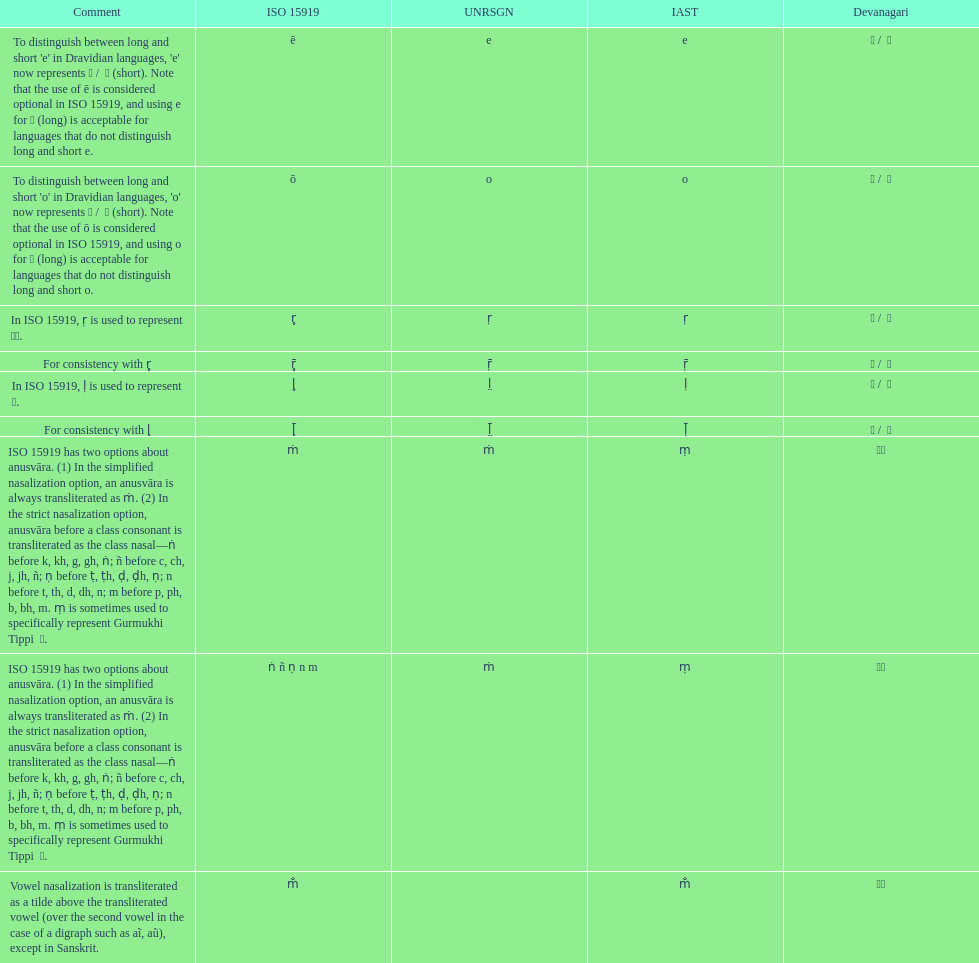What is the total number of translations? 8. Could you parse the entire table as a dict? {'header': ['Comment', 'ISO 15919', 'UNRSGN', 'IAST', 'Devanagari'], 'rows': [["To distinguish between long and short 'e' in Dravidian languages, 'e' now represents ऎ / \xa0ॆ (short). Note that the use of ē is considered optional in ISO 15919, and using e for ए (long) is acceptable for languages that do not distinguish long and short e.", 'ē', 'e', 'e', 'ए / \xa0े'], ["To distinguish between long and short 'o' in Dravidian languages, 'o' now represents ऒ / \xa0ॊ (short). Note that the use of ō is considered optional in ISO 15919, and using o for ओ (long) is acceptable for languages that do not distinguish long and short o.", 'ō', 'o', 'o', 'ओ / \xa0ो'], ['In ISO 15919, ṛ is used to represent ड़.', 'r̥', 'ṛ', 'ṛ', 'ऋ / \xa0ृ'], ['For consistency with r̥', 'r̥̄', 'ṝ', 'ṝ', 'ॠ / \xa0ॄ'], ['In ISO 15919, ḷ is used to represent ळ.', 'l̥', 'l̤', 'ḷ', 'ऌ / \xa0ॢ'], ['For consistency with l̥', 'l̥̄', 'l̤̄', 'ḹ', 'ॡ / \xa0ॣ'], ['ISO 15919 has two options about anusvāra. (1) In the simplified nasalization option, an anusvāra is always transliterated as ṁ. (2) In the strict nasalization option, anusvāra before a class consonant is transliterated as the class nasal—ṅ before k, kh, g, gh, ṅ; ñ before c, ch, j, jh, ñ; ṇ before ṭ, ṭh, ḍ, ḍh, ṇ; n before t, th, d, dh, n; m before p, ph, b, bh, m. ṃ is sometimes used to specifically represent Gurmukhi Tippi \xa0ੰ.', 'ṁ', 'ṁ', 'ṃ', '◌ं'], ['ISO 15919 has two options about anusvāra. (1) In the simplified nasalization option, an anusvāra is always transliterated as ṁ. (2) In the strict nasalization option, anusvāra before a class consonant is transliterated as the class nasal—ṅ before k, kh, g, gh, ṅ; ñ before c, ch, j, jh, ñ; ṇ before ṭ, ṭh, ḍ, ḍh, ṇ; n before t, th, d, dh, n; m before p, ph, b, bh, m. ṃ is sometimes used to specifically represent Gurmukhi Tippi \xa0ੰ.', 'ṅ ñ ṇ n m', 'ṁ', 'ṃ', '◌ं'], ['Vowel nasalization is transliterated as a tilde above the transliterated vowel (over the second vowel in the case of a digraph such as aĩ, aũ), except in Sanskrit.', 'm̐', '', 'm̐', '◌ँ']]} 